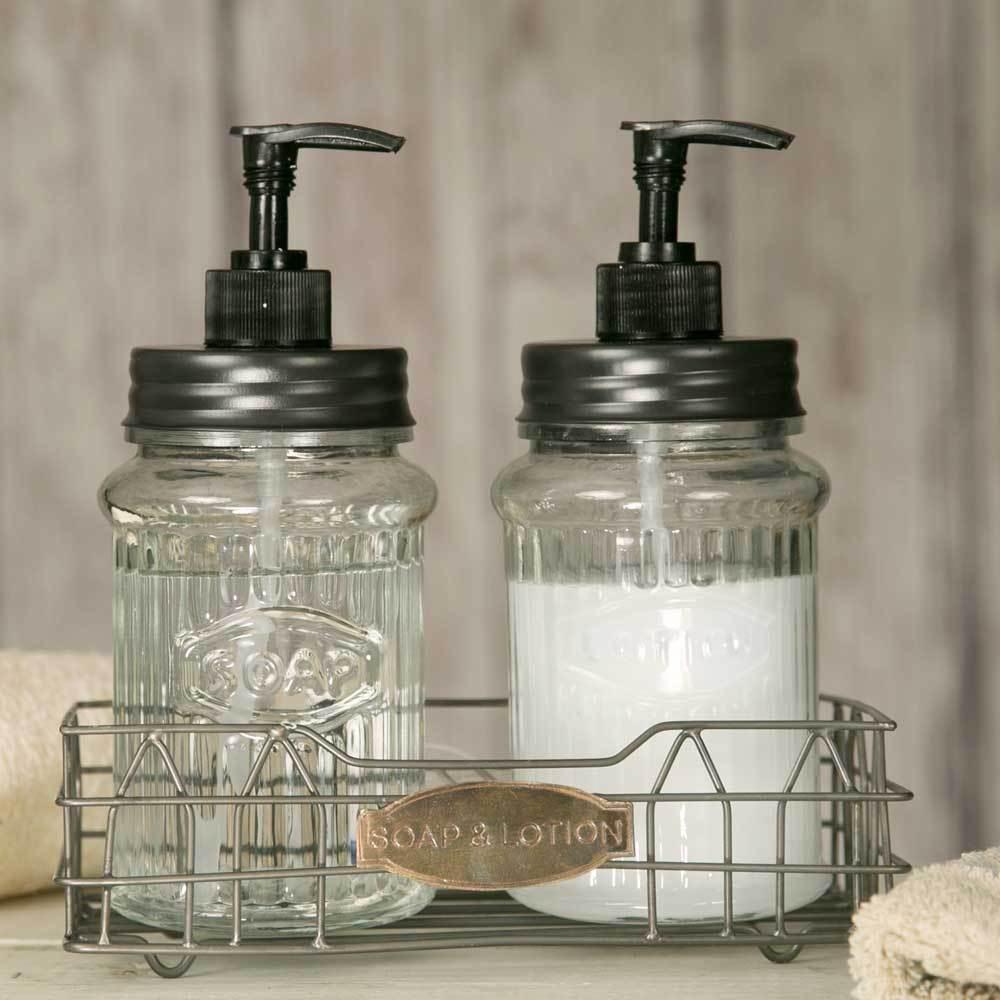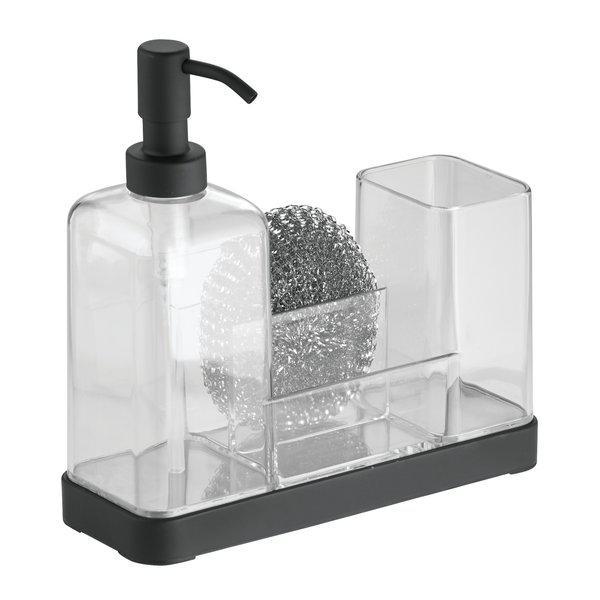The first image is the image on the left, the second image is the image on the right. Considering the images on both sides, is "There are exactly three liquid soap dispenser pumps." valid? Answer yes or no. Yes. The first image is the image on the left, the second image is the image on the right. For the images displayed, is the sentence "None of the soap dispensers have stainless steel tops and at least two of the dispensers are made of clear glass." factually correct? Answer yes or no. Yes. 